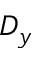<formula> <loc_0><loc_0><loc_500><loc_500>D _ { y }</formula> 